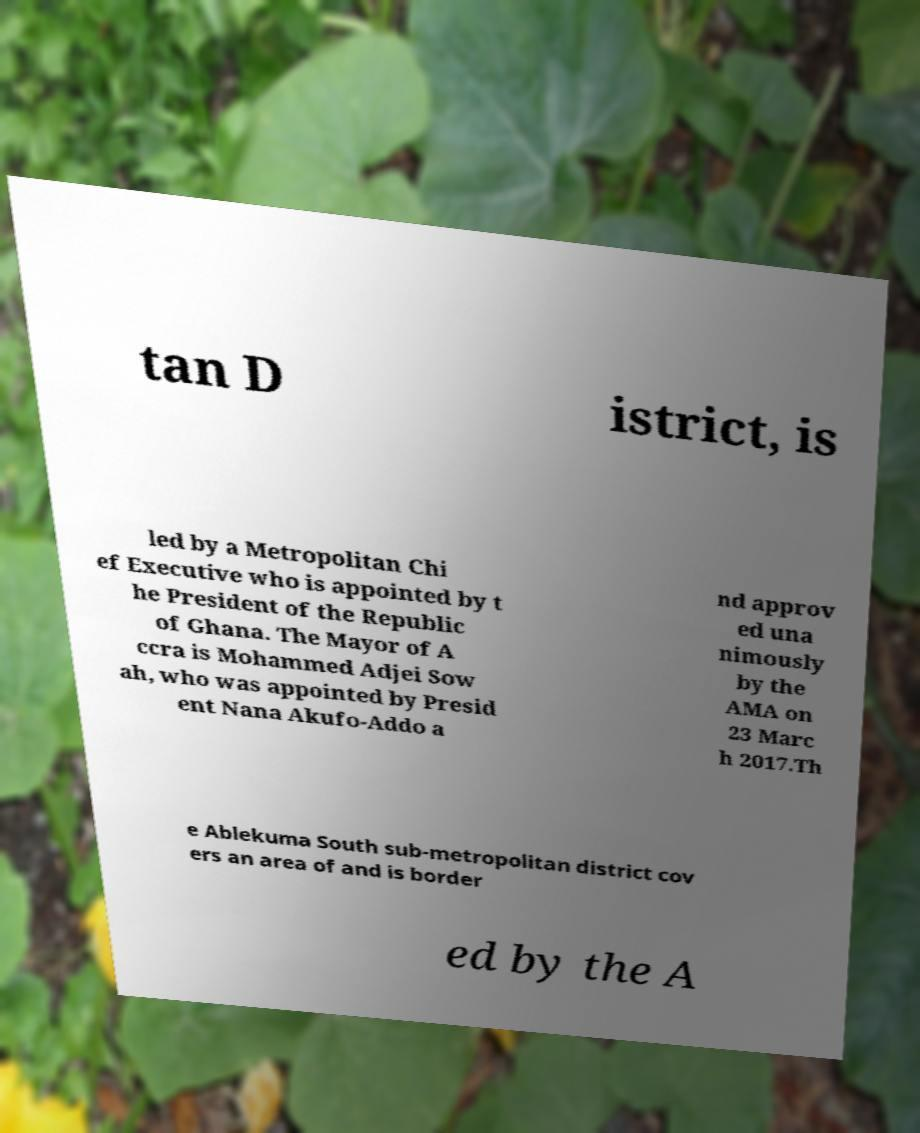Please read and relay the text visible in this image. What does it say? tan D istrict, is led by a Metropolitan Chi ef Executive who is appointed by t he President of the Republic of Ghana. The Mayor of A ccra is Mohammed Adjei Sow ah, who was appointed by Presid ent Nana Akufo-Addo a nd approv ed una nimously by the AMA on 23 Marc h 2017.Th e Ablekuma South sub-metropolitan district cov ers an area of and is border ed by the A 